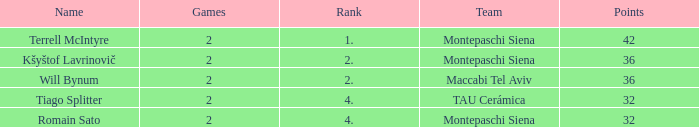What is the highest game that has 32 points and a team rank larger than 4 named montepaschi siena None. 